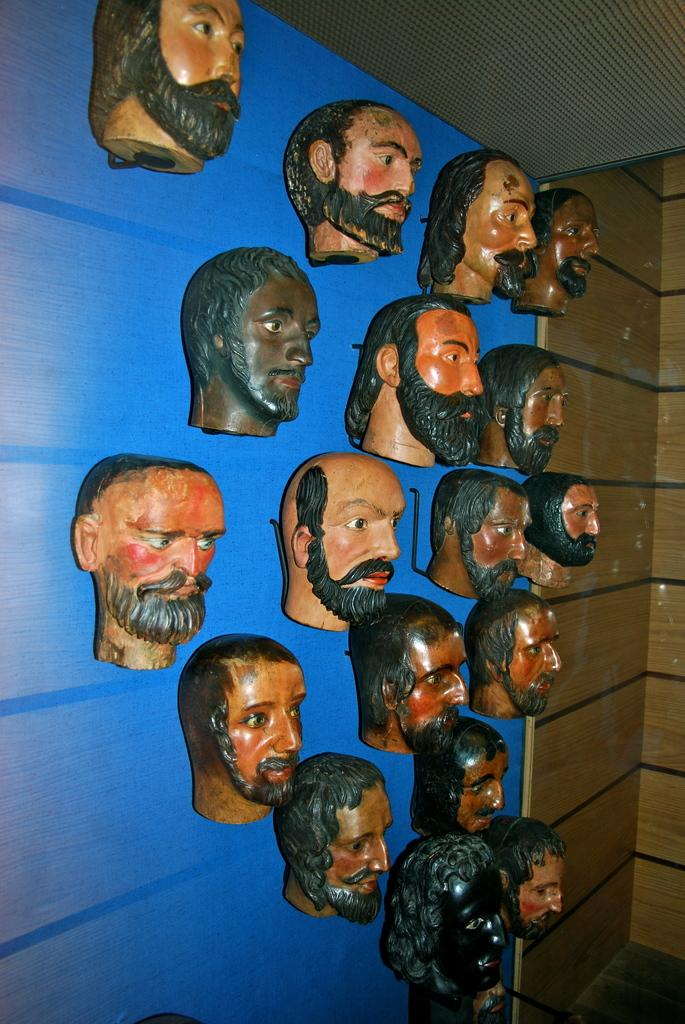What is depicted on the wall in the image? There are depictions of a person's head hanging on the wall in the image. What type of stamp is shown on the person's head in the image? There is no stamp present on the person's head in the image. How many bombs are visible in the image? There are no bombs present in the image. 